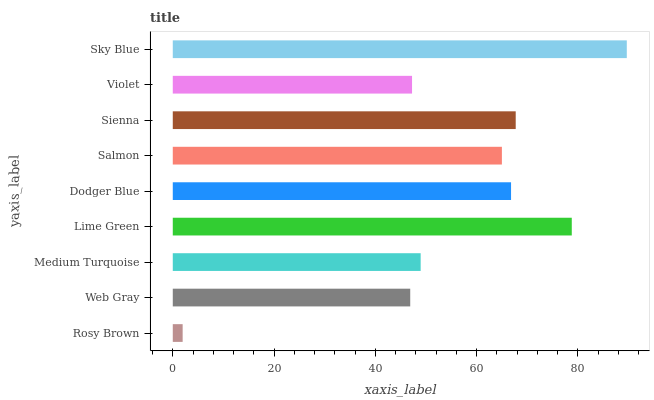Is Rosy Brown the minimum?
Answer yes or no. Yes. Is Sky Blue the maximum?
Answer yes or no. Yes. Is Web Gray the minimum?
Answer yes or no. No. Is Web Gray the maximum?
Answer yes or no. No. Is Web Gray greater than Rosy Brown?
Answer yes or no. Yes. Is Rosy Brown less than Web Gray?
Answer yes or no. Yes. Is Rosy Brown greater than Web Gray?
Answer yes or no. No. Is Web Gray less than Rosy Brown?
Answer yes or no. No. Is Salmon the high median?
Answer yes or no. Yes. Is Salmon the low median?
Answer yes or no. Yes. Is Sky Blue the high median?
Answer yes or no. No. Is Sky Blue the low median?
Answer yes or no. No. 